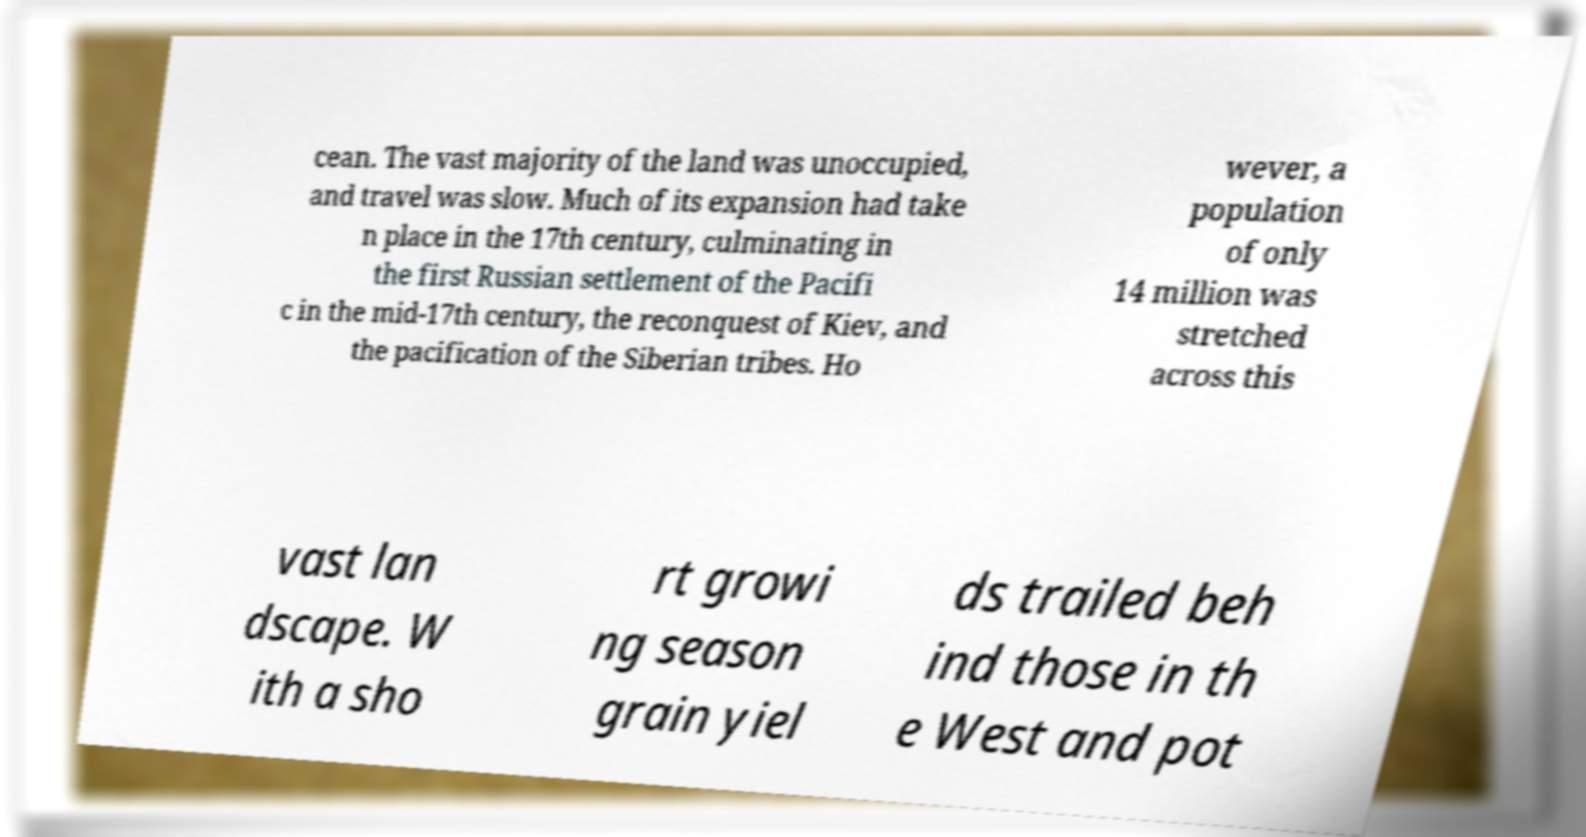What messages or text are displayed in this image? I need them in a readable, typed format. cean. The vast majority of the land was unoccupied, and travel was slow. Much of its expansion had take n place in the 17th century, culminating in the first Russian settlement of the Pacifi c in the mid-17th century, the reconquest of Kiev, and the pacification of the Siberian tribes. Ho wever, a population of only 14 million was stretched across this vast lan dscape. W ith a sho rt growi ng season grain yiel ds trailed beh ind those in th e West and pot 